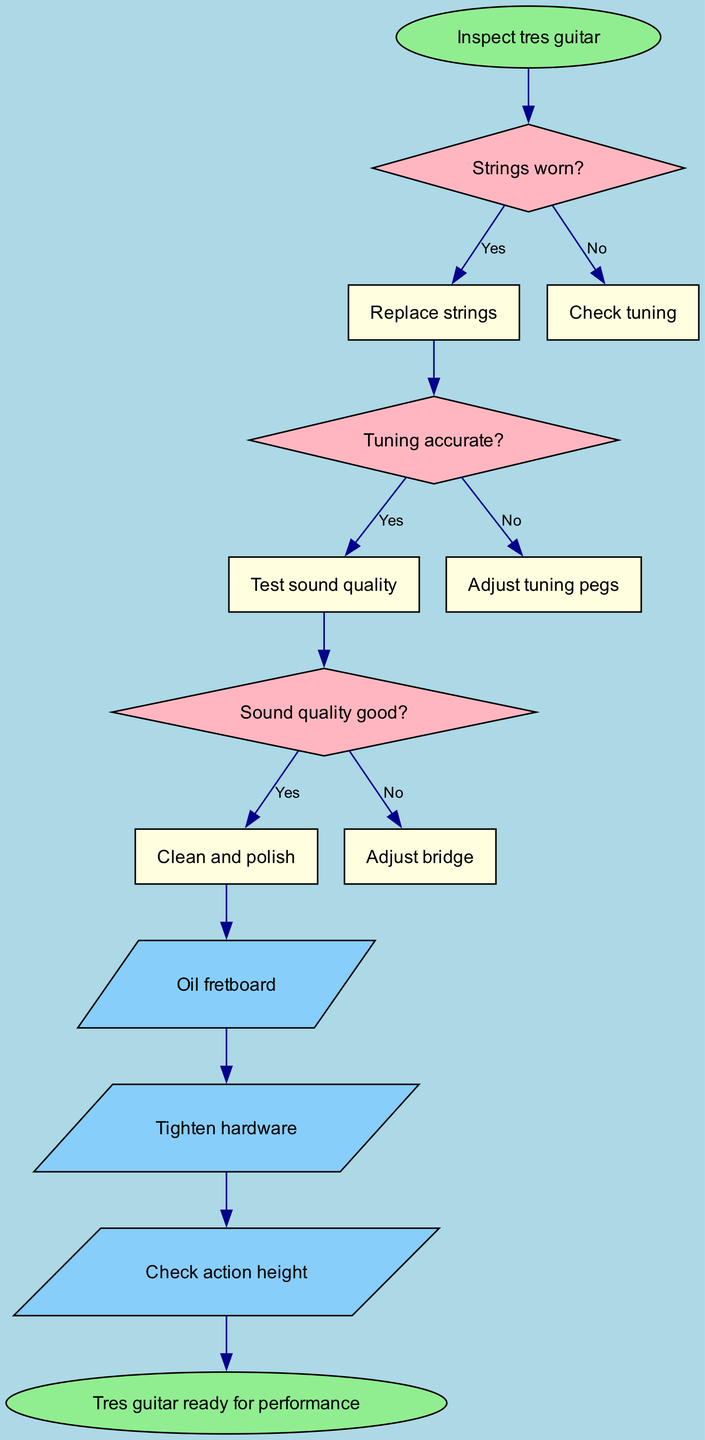What is the first step in maintaining the tres guitar? The diagram starts with the node "Inspect tres guitar," indicating that this is the initial action in the process of maintaining the instrument.
Answer: Inspect tres guitar How many decision points are there in the process? The diagram contains three decision points, each represented by a diamond shape where a question is posed about the state of the guitar.
Answer: 3 What action must be taken if the strings are worn? According to the flow, if the strings are identified as worn (the condition is met), the action following is to "Replace strings."
Answer: Replace strings If the tuning is not accurate, what is the next step? If the tuning is determined to be inaccurate based on the condition asked, the diagram indicates that the next step is to "Adjust tuning pegs."
Answer: Adjust tuning pegs What action occurs if the sound quality is good? If the sound quality is confirmed to be good after the corresponding check, the action to be performed next is to "Clean and polish."
Answer: Clean and polish What is the last action before the guitar is ready for performance? The final action before reaching the end node "Tres guitar ready for performance" is represented as "Check action height," which is part of the actions taken after sound quality checks.
Answer: Check action height What do you do if the sound quality is not good? The diagram states that if the sound quality is lacking, the subsequent action is to "Adjust bridge," which is a corrective measure.
Answer: Adjust bridge In the flow, which node leads to cleaning and polishing the guitar? The flow indicates that the cleaning and polishing step comes after confirming the sound quality is good, leading from the decision node "Sound quality good?" to the action node "Clean and polish."
Answer: Sound quality good? 